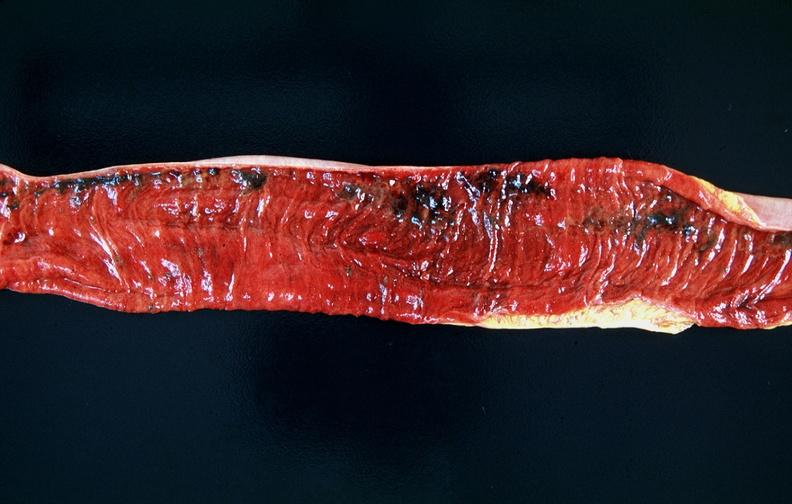does sacrococcygeal teratoma show small intestine, multifocal ulcers and hemorrhages, mucosal congestion?
Answer the question using a single word or phrase. No 